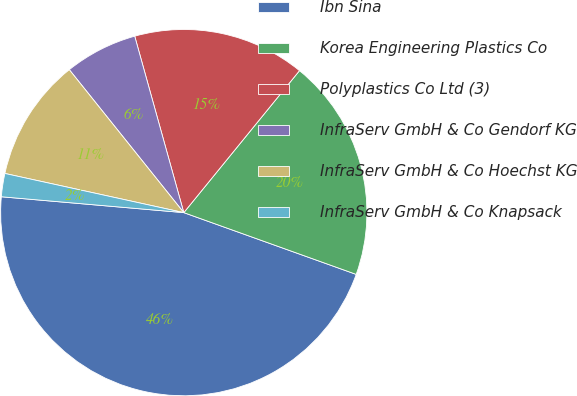<chart> <loc_0><loc_0><loc_500><loc_500><pie_chart><fcel>Ibn Sina<fcel>Korea Engineering Plastics Co<fcel>Polyplastics Co Ltd (3)<fcel>InfraServ GmbH & Co Gendorf KG<fcel>InfraServ GmbH & Co Hoechst KG<fcel>InfraServ GmbH & Co Knapsack<nl><fcel>45.9%<fcel>19.59%<fcel>15.2%<fcel>6.43%<fcel>10.82%<fcel>2.05%<nl></chart> 